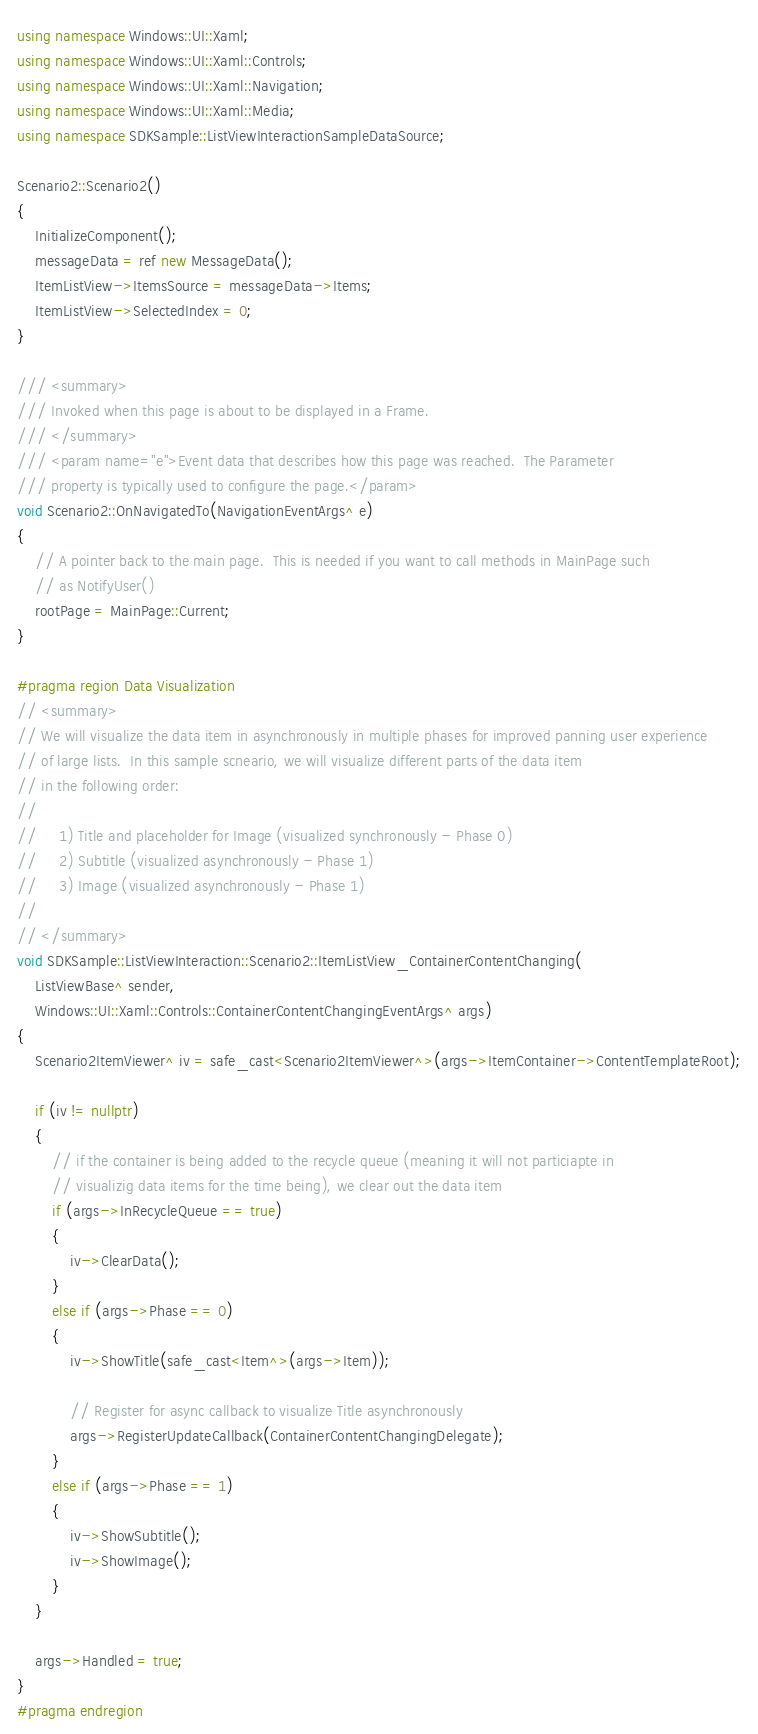Convert code to text. <code><loc_0><loc_0><loc_500><loc_500><_C++_>using namespace Windows::UI::Xaml;
using namespace Windows::UI::Xaml::Controls;
using namespace Windows::UI::Xaml::Navigation;
using namespace Windows::UI::Xaml::Media;
using namespace SDKSample::ListViewInteractionSampleDataSource;

Scenario2::Scenario2()
{
    InitializeComponent();
    messageData = ref new MessageData();
    ItemListView->ItemsSource = messageData->Items;
    ItemListView->SelectedIndex = 0;
}

/// <summary>
/// Invoked when this page is about to be displayed in a Frame.
/// </summary>
/// <param name="e">Event data that describes how this page was reached.  The Parameter
/// property is typically used to configure the page.</param>
void Scenario2::OnNavigatedTo(NavigationEventArgs^ e)
{
    // A pointer back to the main page.  This is needed if you want to call methods in MainPage such
    // as NotifyUser()
    rootPage = MainPage::Current;
}

#pragma region Data Visualization
// <summary>
// We will visualize the data item in asynchronously in multiple phases for improved panning user experience 
// of large lists.  In this sample scneario, we will visualize different parts of the data item
// in the following order:
// 
//     1) Title and placeholder for Image (visualized synchronously - Phase 0)
//     2) Subtitle (visualized asynchronously - Phase 1)
//     3) Image (visualized asynchronously - Phase 1)
//
// </summary>
void SDKSample::ListViewInteraction::Scenario2::ItemListView_ContainerContentChanging(
    ListViewBase^ sender,
    Windows::UI::Xaml::Controls::ContainerContentChangingEventArgs^ args)
{
    Scenario2ItemViewer^ iv = safe_cast<Scenario2ItemViewer^>(args->ItemContainer->ContentTemplateRoot);

    if (iv != nullptr)
    {
        // if the container is being added to the recycle queue (meaning it will not particiapte in 
        // visualizig data items for the time being), we clear out the data item
        if (args->InRecycleQueue == true)
        {
            iv->ClearData();
        }
        else if (args->Phase == 0)
        {
            iv->ShowTitle(safe_cast<Item^>(args->Item));

            // Register for async callback to visualize Title asynchronously
            args->RegisterUpdateCallback(ContainerContentChangingDelegate);
        }
        else if (args->Phase == 1)
        {
            iv->ShowSubtitle();
            iv->ShowImage();
        }
    }

    args->Handled = true;
}
#pragma endregion



</code> 